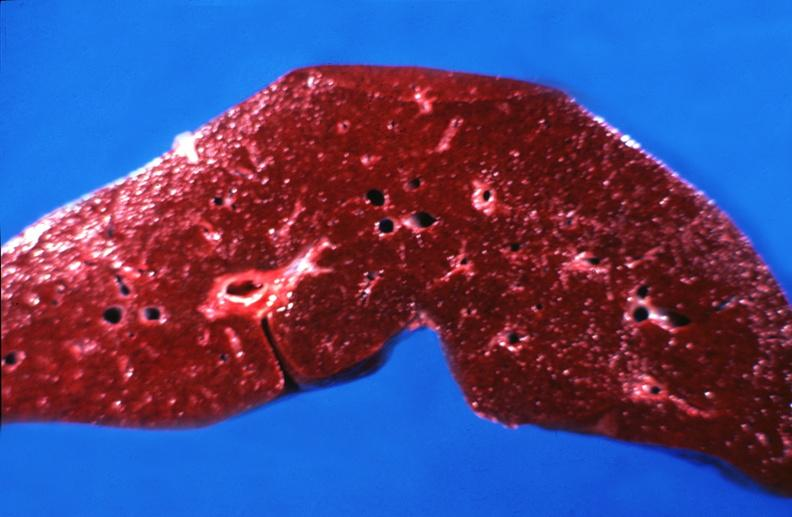does an opened peritoneal cavity cause by fibrous band strangulation show hemochromatosis?
Answer the question using a single word or phrase. No 